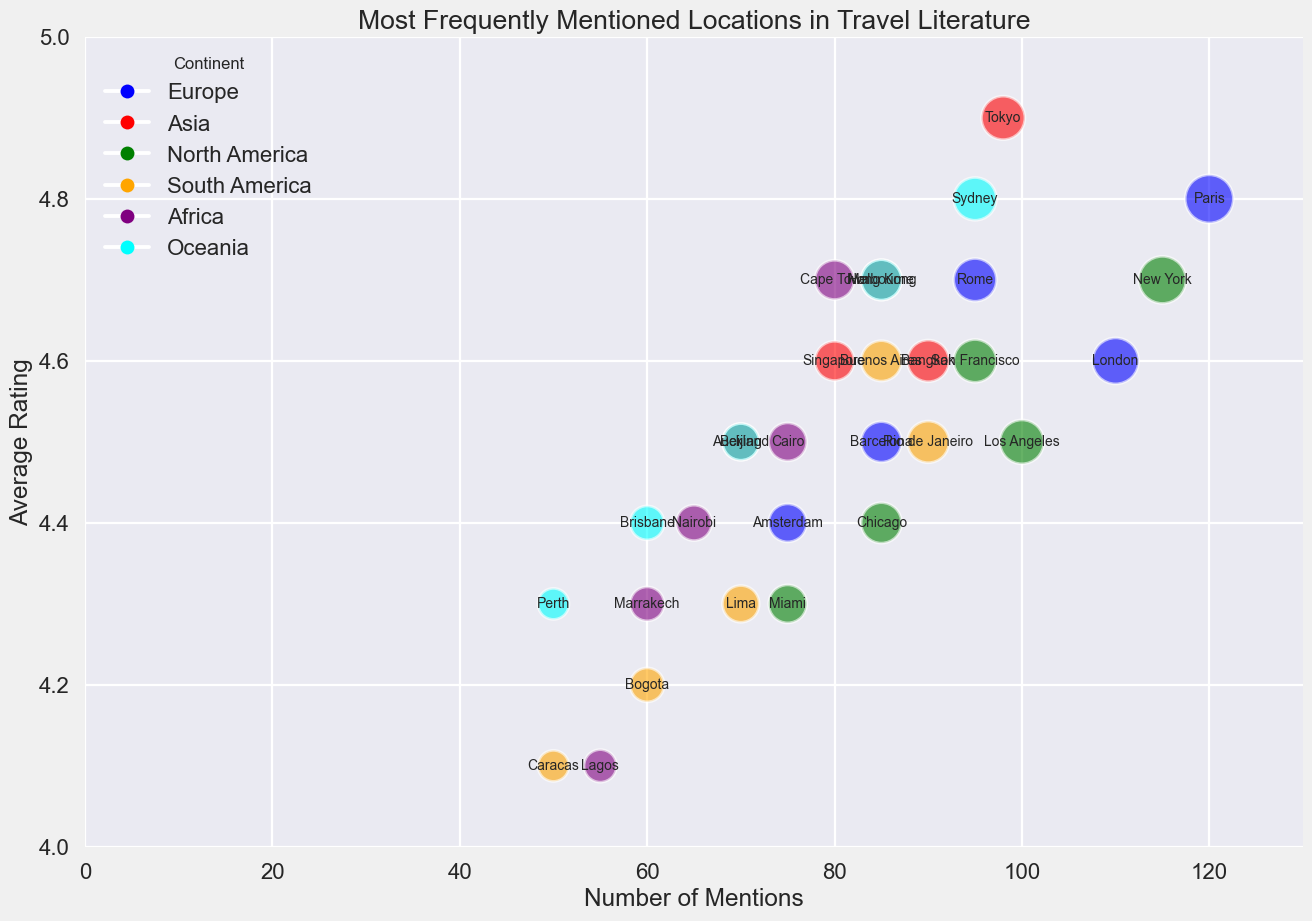Which location has the highest average rating? The highest average rating is visible at the top of the chart. Tokyo has the highest rating of 4.9.
Answer: Tokyo Which continent has the most locations with ratings of 4.6 and above? By looking at the colors representing continents and counting the locations with ratings of 4.6 and above, Europe has the most locations fitting this criterion (Paris, London, Rome).
Answer: Europe What is the total number of mentions for locations in Asia? Sum up the mentions for all Asia locations: Tokyo (98) + Bangkok (90) + Hong Kong (85) + Singapore (80) + Beijing (70) = 423.
Answer: 423 Which locations have the same number of mentions and what are they? Look for locations with bubbles of equal sizes and compare their labels; London and Bangkok both have 90 mentions.
Answer: London and Bangkok Which location has more mentions, San Francisco or Sydney? Compare the position of San Francisco and Sydney on the x-axis representing mentions; San Francisco has 95 mentions, whereas Sydney also has 95. Hence, they are equal.
Answer: Same Are there any locations with an average rating of 4.7 in more than one continent? Check which locations have the same average rating of 4.7 across different continents. Rome in Europe, Hong Kong in Asia, San Francisco in North America, and Cape Town in Africa all have a rating of 4.7.
Answer: Yes Which continent has the highest average rating for its most mentioned location? Determine the highest-mentioned location from each continent and their ratings: Paris (Europe) with 120 mentions and a rating of 4.8, Tokyo (Asia) with 98 and 4.9, New York (North America) with 115 and 4.7, Rio de Janeiro (South America) with 90 and 4.5, Cape Town (Africa) with 80 and 4.7, Sydney (Oceania) with 95 and 4.8. Asia's Tokyo has the highest rating at 4.9.
Answer: Asia Which location has fewer mentions, Marrakeck or Lima, and by how much? Locate Marrakeck and Lima on the x-axis representing mentions: Lima has 70 mentions, Marrakeck has 60. Difference is 70 - 60 = 10.
Answer: Marrakeck by 10 Which continent's most mentioned location has the lowest average rating? Identify the most mentioned location from each continent and compare their ratings: Lagos (Africa) has 55 mentions and a rating of 4.1, which is the lowest among the most mentioned per continent.
Answer: Africa 